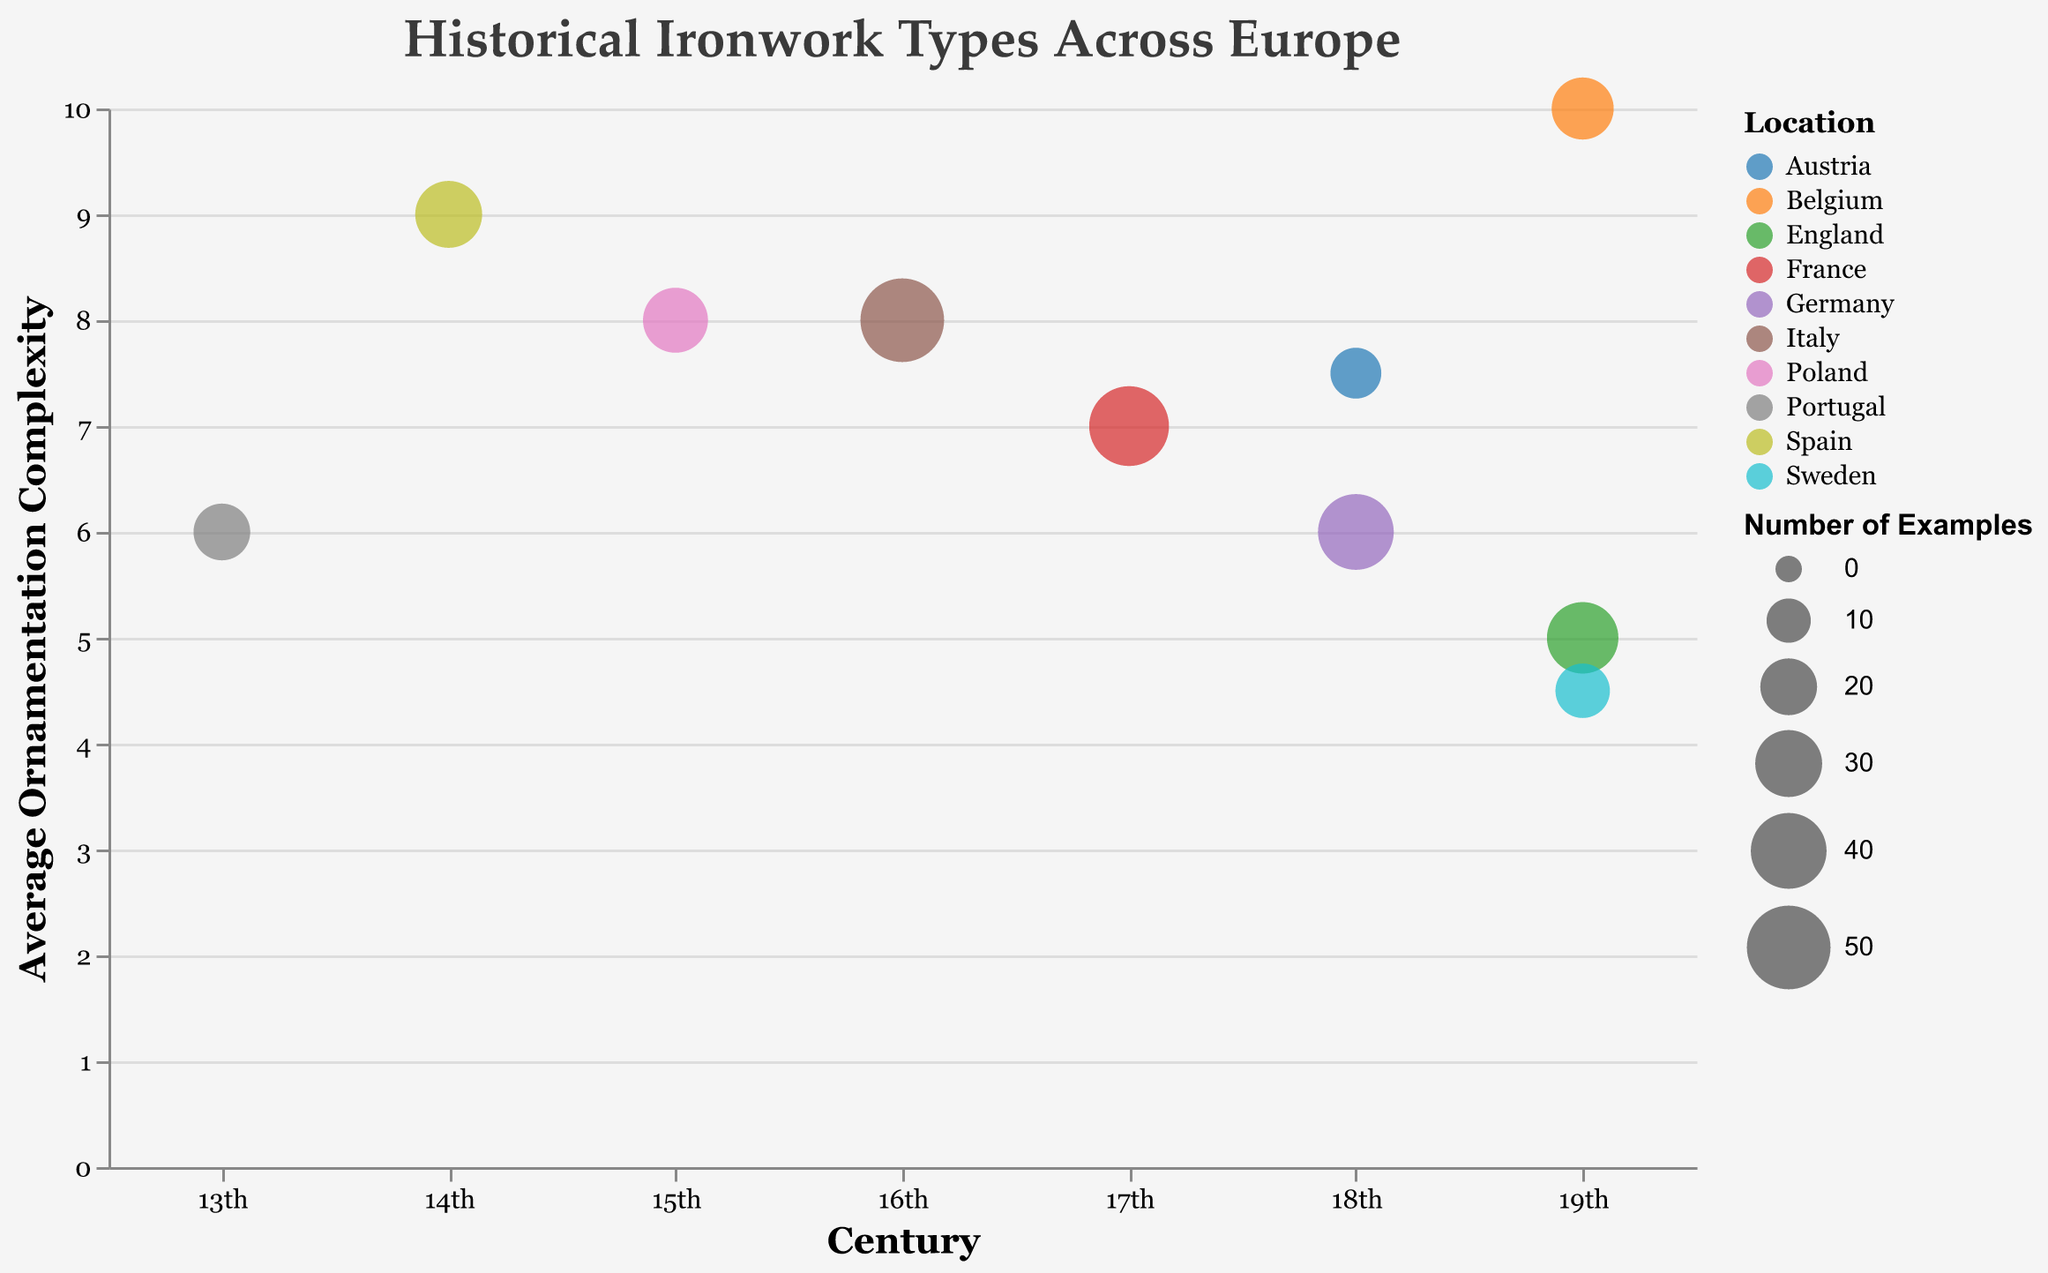What type of ironwork has the highest average ornamentation complexity? The bubble at the top of the vertical axis, corresponding to "Average Ornamentation Complexity," represents the highest value. The highest value is 10, and it is associated with "Art Nouveau Balustrades" from Belgium.
Answer: Art Nouveau Balustrades Which country has the most examples of historical ironwork? The size of the bubbles represents the number of examples. The largest bubble appears at the 16th century and belongs to Italy, indicating 50 examples.
Answer: Italy How does the average ornamentation complexity of Baroque Grilles compare to Rococo Window Guards? Baroque Grilles in Germany have an average ornamentation complexity of 6, while Rococo Window Guards in Austria have a complexity of 7.5. Rococo Window Guards have a higher complexity.
Answer: Rococo Window Guards are more complex In which century do the majority of ironwork examples come from? Counting the bubbles in each century, the 19th century contains three bubbles, the highest count across different centuries.
Answer: 19th century What is the total number of examples of ironwork from the 18th century? Adding the number of examples from the 18th century bubble representing Baroque Grilles (40) and Rococo Window Guards (15) gives a total of 55 examples.
Answer: 55 Which ironwork type in the 19th century has the most complex ornamentation? In the 19th century, there are bubbles for Victorian Fences (complexity 5), Art Nouveau Balustrades (complexity 10), and Classicist Door Knockers (complexity 4.5). Art Nouveau Balustrades have the highest complexity.
Answer: Art Nouveau Balustrades What is the difference in the number of examples between the Gothic Railings and Iron Crosses? Gothic Railings (14th century, Spain) have 30 examples, and Iron Crosses (15th century, Poland) have 28 examples. Subtracting 28 from 30 yields a difference of 2.
Answer: 2 Which country's ironwork example falls in the 14th century? The bubble corresponding to the 14th century represents Gothic Railings, located in Spain.
Answer: Spain 